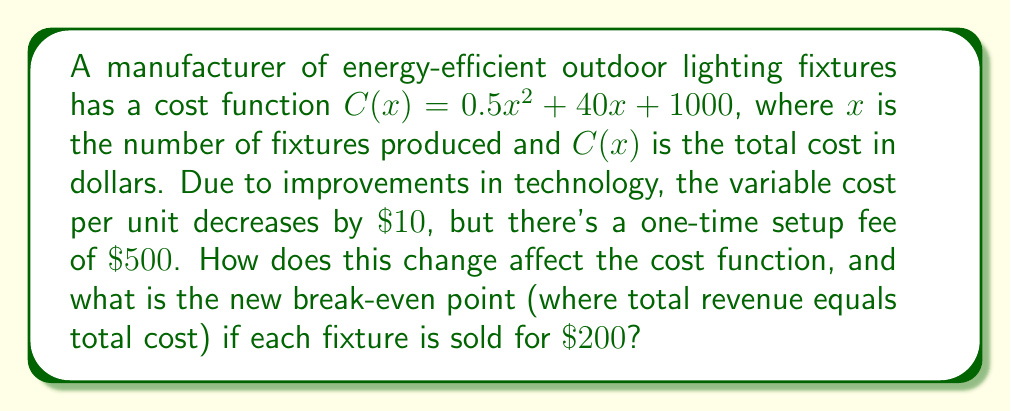Give your solution to this math problem. 1) The original cost function is $C(x) = 0.5x^2 + 40x + 1000$.

2) The variable cost decrease of $\$10$ per unit affects the linear term:
   $40x$ becomes $(40-10)x = 30x$

3) The one-time setup fee of $\$500$ increases the constant term:
   $1000$ becomes $1000 + 500 = 1500$

4) The new cost function is:
   $C_{new}(x) = 0.5x^2 + 30x + 1500$

5) To find the break-even point, we set the new cost function equal to the revenue function:
   $C_{new}(x) = R(x)$
   $0.5x^2 + 30x + 1500 = 200x$

6) Rearranging the equation:
   $0.5x^2 - 170x + 1500 = 0$

7) This is a quadratic equation. We can solve it using the quadratic formula:
   $x = \frac{-b \pm \sqrt{b^2 - 4ac}}{2a}$

   Where $a = 0.5$, $b = -170$, and $c = 1500$

8) Plugging in these values:
   $x = \frac{170 \pm \sqrt{(-170)^2 - 4(0.5)(1500)}}{2(0.5)}$

9) Simplifying:
   $x = \frac{170 \pm \sqrt{28900 - 3000}}{1} = \frac{170 \pm \sqrt{25900}}{1} = \frac{170 \pm 161}{1}$

10) This gives us two solutions:
    $x_1 = 170 + 161 = 331$
    $x_2 = 170 - 161 = 9$

11) The break-even points are at 9 and 331 units. The lower value (9) is the new break-even point we're looking for.
Answer: $C_{new}(x) = 0.5x^2 + 30x + 1500$; New break-even point: 9 units 